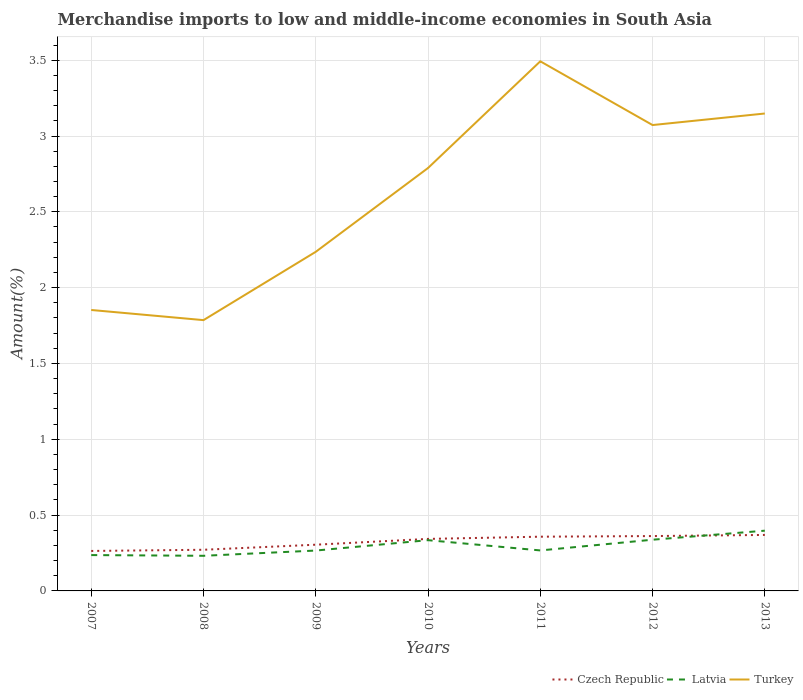Does the line corresponding to Latvia intersect with the line corresponding to Czech Republic?
Provide a short and direct response. Yes. Across all years, what is the maximum percentage of amount earned from merchandise imports in Latvia?
Your response must be concise. 0.23. What is the total percentage of amount earned from merchandise imports in Latvia in the graph?
Provide a succinct answer. -0.1. What is the difference between the highest and the second highest percentage of amount earned from merchandise imports in Czech Republic?
Offer a terse response. 0.11. How many lines are there?
Keep it short and to the point. 3. How many years are there in the graph?
Ensure brevity in your answer.  7. What is the difference between two consecutive major ticks on the Y-axis?
Your answer should be compact. 0.5. Are the values on the major ticks of Y-axis written in scientific E-notation?
Your response must be concise. No. How many legend labels are there?
Offer a terse response. 3. How are the legend labels stacked?
Offer a very short reply. Horizontal. What is the title of the graph?
Offer a very short reply. Merchandise imports to low and middle-income economies in South Asia. What is the label or title of the X-axis?
Make the answer very short. Years. What is the label or title of the Y-axis?
Your answer should be very brief. Amount(%). What is the Amount(%) in Czech Republic in 2007?
Make the answer very short. 0.26. What is the Amount(%) in Latvia in 2007?
Provide a succinct answer. 0.24. What is the Amount(%) in Turkey in 2007?
Ensure brevity in your answer.  1.85. What is the Amount(%) of Czech Republic in 2008?
Your answer should be very brief. 0.27. What is the Amount(%) of Latvia in 2008?
Ensure brevity in your answer.  0.23. What is the Amount(%) in Turkey in 2008?
Your response must be concise. 1.79. What is the Amount(%) of Czech Republic in 2009?
Offer a very short reply. 0.3. What is the Amount(%) in Latvia in 2009?
Offer a very short reply. 0.27. What is the Amount(%) of Turkey in 2009?
Ensure brevity in your answer.  2.24. What is the Amount(%) of Czech Republic in 2010?
Ensure brevity in your answer.  0.34. What is the Amount(%) in Latvia in 2010?
Provide a succinct answer. 0.33. What is the Amount(%) in Turkey in 2010?
Provide a short and direct response. 2.79. What is the Amount(%) of Czech Republic in 2011?
Your response must be concise. 0.36. What is the Amount(%) of Latvia in 2011?
Your answer should be compact. 0.27. What is the Amount(%) in Turkey in 2011?
Your answer should be very brief. 3.49. What is the Amount(%) in Czech Republic in 2012?
Provide a succinct answer. 0.36. What is the Amount(%) of Latvia in 2012?
Your response must be concise. 0.34. What is the Amount(%) of Turkey in 2012?
Ensure brevity in your answer.  3.07. What is the Amount(%) of Czech Republic in 2013?
Give a very brief answer. 0.37. What is the Amount(%) of Latvia in 2013?
Offer a terse response. 0.4. What is the Amount(%) in Turkey in 2013?
Give a very brief answer. 3.15. Across all years, what is the maximum Amount(%) of Czech Republic?
Your response must be concise. 0.37. Across all years, what is the maximum Amount(%) of Latvia?
Provide a succinct answer. 0.4. Across all years, what is the maximum Amount(%) of Turkey?
Your answer should be compact. 3.49. Across all years, what is the minimum Amount(%) of Czech Republic?
Make the answer very short. 0.26. Across all years, what is the minimum Amount(%) in Latvia?
Provide a succinct answer. 0.23. Across all years, what is the minimum Amount(%) in Turkey?
Provide a succinct answer. 1.79. What is the total Amount(%) in Czech Republic in the graph?
Provide a short and direct response. 2.27. What is the total Amount(%) of Latvia in the graph?
Your response must be concise. 2.07. What is the total Amount(%) in Turkey in the graph?
Your answer should be very brief. 18.38. What is the difference between the Amount(%) of Czech Republic in 2007 and that in 2008?
Make the answer very short. -0.01. What is the difference between the Amount(%) of Latvia in 2007 and that in 2008?
Your answer should be compact. 0. What is the difference between the Amount(%) of Turkey in 2007 and that in 2008?
Make the answer very short. 0.07. What is the difference between the Amount(%) in Czech Republic in 2007 and that in 2009?
Give a very brief answer. -0.04. What is the difference between the Amount(%) of Latvia in 2007 and that in 2009?
Ensure brevity in your answer.  -0.03. What is the difference between the Amount(%) in Turkey in 2007 and that in 2009?
Keep it short and to the point. -0.38. What is the difference between the Amount(%) of Czech Republic in 2007 and that in 2010?
Give a very brief answer. -0.08. What is the difference between the Amount(%) of Latvia in 2007 and that in 2010?
Offer a very short reply. -0.1. What is the difference between the Amount(%) of Turkey in 2007 and that in 2010?
Your response must be concise. -0.94. What is the difference between the Amount(%) in Czech Republic in 2007 and that in 2011?
Ensure brevity in your answer.  -0.09. What is the difference between the Amount(%) in Latvia in 2007 and that in 2011?
Provide a succinct answer. -0.03. What is the difference between the Amount(%) of Turkey in 2007 and that in 2011?
Keep it short and to the point. -1.64. What is the difference between the Amount(%) in Czech Republic in 2007 and that in 2012?
Offer a terse response. -0.1. What is the difference between the Amount(%) in Latvia in 2007 and that in 2012?
Make the answer very short. -0.1. What is the difference between the Amount(%) in Turkey in 2007 and that in 2012?
Your answer should be very brief. -1.22. What is the difference between the Amount(%) of Czech Republic in 2007 and that in 2013?
Keep it short and to the point. -0.11. What is the difference between the Amount(%) in Latvia in 2007 and that in 2013?
Offer a terse response. -0.16. What is the difference between the Amount(%) in Turkey in 2007 and that in 2013?
Offer a very short reply. -1.3. What is the difference between the Amount(%) in Czech Republic in 2008 and that in 2009?
Your answer should be compact. -0.03. What is the difference between the Amount(%) of Latvia in 2008 and that in 2009?
Offer a terse response. -0.03. What is the difference between the Amount(%) in Turkey in 2008 and that in 2009?
Offer a very short reply. -0.45. What is the difference between the Amount(%) in Czech Republic in 2008 and that in 2010?
Keep it short and to the point. -0.07. What is the difference between the Amount(%) of Latvia in 2008 and that in 2010?
Make the answer very short. -0.1. What is the difference between the Amount(%) in Turkey in 2008 and that in 2010?
Provide a succinct answer. -1. What is the difference between the Amount(%) of Czech Republic in 2008 and that in 2011?
Your answer should be compact. -0.09. What is the difference between the Amount(%) in Latvia in 2008 and that in 2011?
Your response must be concise. -0.04. What is the difference between the Amount(%) in Turkey in 2008 and that in 2011?
Offer a very short reply. -1.71. What is the difference between the Amount(%) of Czech Republic in 2008 and that in 2012?
Your answer should be very brief. -0.09. What is the difference between the Amount(%) of Latvia in 2008 and that in 2012?
Provide a short and direct response. -0.11. What is the difference between the Amount(%) of Turkey in 2008 and that in 2012?
Offer a terse response. -1.29. What is the difference between the Amount(%) in Czech Republic in 2008 and that in 2013?
Make the answer very short. -0.1. What is the difference between the Amount(%) of Latvia in 2008 and that in 2013?
Offer a very short reply. -0.17. What is the difference between the Amount(%) of Turkey in 2008 and that in 2013?
Your answer should be very brief. -1.36. What is the difference between the Amount(%) of Czech Republic in 2009 and that in 2010?
Give a very brief answer. -0.04. What is the difference between the Amount(%) in Latvia in 2009 and that in 2010?
Ensure brevity in your answer.  -0.07. What is the difference between the Amount(%) in Turkey in 2009 and that in 2010?
Offer a terse response. -0.55. What is the difference between the Amount(%) of Czech Republic in 2009 and that in 2011?
Ensure brevity in your answer.  -0.05. What is the difference between the Amount(%) in Latvia in 2009 and that in 2011?
Your response must be concise. -0. What is the difference between the Amount(%) of Turkey in 2009 and that in 2011?
Ensure brevity in your answer.  -1.26. What is the difference between the Amount(%) in Czech Republic in 2009 and that in 2012?
Keep it short and to the point. -0.06. What is the difference between the Amount(%) of Latvia in 2009 and that in 2012?
Your answer should be very brief. -0.07. What is the difference between the Amount(%) in Turkey in 2009 and that in 2012?
Offer a terse response. -0.84. What is the difference between the Amount(%) in Czech Republic in 2009 and that in 2013?
Provide a succinct answer. -0.06. What is the difference between the Amount(%) of Latvia in 2009 and that in 2013?
Ensure brevity in your answer.  -0.13. What is the difference between the Amount(%) of Turkey in 2009 and that in 2013?
Your answer should be very brief. -0.91. What is the difference between the Amount(%) of Czech Republic in 2010 and that in 2011?
Ensure brevity in your answer.  -0.01. What is the difference between the Amount(%) in Latvia in 2010 and that in 2011?
Your response must be concise. 0.07. What is the difference between the Amount(%) of Turkey in 2010 and that in 2011?
Ensure brevity in your answer.  -0.7. What is the difference between the Amount(%) of Czech Republic in 2010 and that in 2012?
Offer a terse response. -0.02. What is the difference between the Amount(%) in Latvia in 2010 and that in 2012?
Give a very brief answer. -0. What is the difference between the Amount(%) in Turkey in 2010 and that in 2012?
Keep it short and to the point. -0.28. What is the difference between the Amount(%) of Czech Republic in 2010 and that in 2013?
Ensure brevity in your answer.  -0.03. What is the difference between the Amount(%) in Latvia in 2010 and that in 2013?
Your response must be concise. -0.06. What is the difference between the Amount(%) in Turkey in 2010 and that in 2013?
Ensure brevity in your answer.  -0.36. What is the difference between the Amount(%) of Czech Republic in 2011 and that in 2012?
Provide a short and direct response. -0. What is the difference between the Amount(%) in Latvia in 2011 and that in 2012?
Provide a succinct answer. -0.07. What is the difference between the Amount(%) of Turkey in 2011 and that in 2012?
Your response must be concise. 0.42. What is the difference between the Amount(%) of Czech Republic in 2011 and that in 2013?
Offer a very short reply. -0.01. What is the difference between the Amount(%) in Latvia in 2011 and that in 2013?
Keep it short and to the point. -0.13. What is the difference between the Amount(%) in Turkey in 2011 and that in 2013?
Your response must be concise. 0.34. What is the difference between the Amount(%) of Czech Republic in 2012 and that in 2013?
Provide a short and direct response. -0.01. What is the difference between the Amount(%) in Latvia in 2012 and that in 2013?
Make the answer very short. -0.06. What is the difference between the Amount(%) in Turkey in 2012 and that in 2013?
Your response must be concise. -0.08. What is the difference between the Amount(%) in Czech Republic in 2007 and the Amount(%) in Latvia in 2008?
Offer a very short reply. 0.03. What is the difference between the Amount(%) of Czech Republic in 2007 and the Amount(%) of Turkey in 2008?
Your answer should be compact. -1.52. What is the difference between the Amount(%) of Latvia in 2007 and the Amount(%) of Turkey in 2008?
Provide a succinct answer. -1.55. What is the difference between the Amount(%) of Czech Republic in 2007 and the Amount(%) of Latvia in 2009?
Provide a succinct answer. -0. What is the difference between the Amount(%) of Czech Republic in 2007 and the Amount(%) of Turkey in 2009?
Your answer should be compact. -1.97. What is the difference between the Amount(%) of Latvia in 2007 and the Amount(%) of Turkey in 2009?
Provide a succinct answer. -2. What is the difference between the Amount(%) of Czech Republic in 2007 and the Amount(%) of Latvia in 2010?
Your answer should be compact. -0.07. What is the difference between the Amount(%) of Czech Republic in 2007 and the Amount(%) of Turkey in 2010?
Offer a very short reply. -2.53. What is the difference between the Amount(%) of Latvia in 2007 and the Amount(%) of Turkey in 2010?
Give a very brief answer. -2.55. What is the difference between the Amount(%) of Czech Republic in 2007 and the Amount(%) of Latvia in 2011?
Provide a short and direct response. -0. What is the difference between the Amount(%) in Czech Republic in 2007 and the Amount(%) in Turkey in 2011?
Offer a very short reply. -3.23. What is the difference between the Amount(%) in Latvia in 2007 and the Amount(%) in Turkey in 2011?
Provide a short and direct response. -3.26. What is the difference between the Amount(%) of Czech Republic in 2007 and the Amount(%) of Latvia in 2012?
Your response must be concise. -0.07. What is the difference between the Amount(%) of Czech Republic in 2007 and the Amount(%) of Turkey in 2012?
Offer a very short reply. -2.81. What is the difference between the Amount(%) of Latvia in 2007 and the Amount(%) of Turkey in 2012?
Offer a terse response. -2.84. What is the difference between the Amount(%) in Czech Republic in 2007 and the Amount(%) in Latvia in 2013?
Give a very brief answer. -0.13. What is the difference between the Amount(%) in Czech Republic in 2007 and the Amount(%) in Turkey in 2013?
Your response must be concise. -2.88. What is the difference between the Amount(%) of Latvia in 2007 and the Amount(%) of Turkey in 2013?
Provide a succinct answer. -2.91. What is the difference between the Amount(%) of Czech Republic in 2008 and the Amount(%) of Latvia in 2009?
Provide a short and direct response. 0.01. What is the difference between the Amount(%) in Czech Republic in 2008 and the Amount(%) in Turkey in 2009?
Ensure brevity in your answer.  -1.97. What is the difference between the Amount(%) of Latvia in 2008 and the Amount(%) of Turkey in 2009?
Offer a terse response. -2. What is the difference between the Amount(%) in Czech Republic in 2008 and the Amount(%) in Latvia in 2010?
Give a very brief answer. -0.06. What is the difference between the Amount(%) in Czech Republic in 2008 and the Amount(%) in Turkey in 2010?
Provide a succinct answer. -2.52. What is the difference between the Amount(%) in Latvia in 2008 and the Amount(%) in Turkey in 2010?
Offer a terse response. -2.56. What is the difference between the Amount(%) in Czech Republic in 2008 and the Amount(%) in Latvia in 2011?
Ensure brevity in your answer.  0. What is the difference between the Amount(%) in Czech Republic in 2008 and the Amount(%) in Turkey in 2011?
Provide a succinct answer. -3.22. What is the difference between the Amount(%) of Latvia in 2008 and the Amount(%) of Turkey in 2011?
Your answer should be compact. -3.26. What is the difference between the Amount(%) of Czech Republic in 2008 and the Amount(%) of Latvia in 2012?
Give a very brief answer. -0.07. What is the difference between the Amount(%) in Czech Republic in 2008 and the Amount(%) in Turkey in 2012?
Offer a very short reply. -2.8. What is the difference between the Amount(%) of Latvia in 2008 and the Amount(%) of Turkey in 2012?
Offer a terse response. -2.84. What is the difference between the Amount(%) of Czech Republic in 2008 and the Amount(%) of Latvia in 2013?
Offer a very short reply. -0.13. What is the difference between the Amount(%) in Czech Republic in 2008 and the Amount(%) in Turkey in 2013?
Offer a terse response. -2.88. What is the difference between the Amount(%) in Latvia in 2008 and the Amount(%) in Turkey in 2013?
Your answer should be very brief. -2.92. What is the difference between the Amount(%) in Czech Republic in 2009 and the Amount(%) in Latvia in 2010?
Make the answer very short. -0.03. What is the difference between the Amount(%) of Czech Republic in 2009 and the Amount(%) of Turkey in 2010?
Your answer should be compact. -2.48. What is the difference between the Amount(%) in Latvia in 2009 and the Amount(%) in Turkey in 2010?
Keep it short and to the point. -2.52. What is the difference between the Amount(%) of Czech Republic in 2009 and the Amount(%) of Latvia in 2011?
Offer a very short reply. 0.04. What is the difference between the Amount(%) in Czech Republic in 2009 and the Amount(%) in Turkey in 2011?
Provide a succinct answer. -3.19. What is the difference between the Amount(%) in Latvia in 2009 and the Amount(%) in Turkey in 2011?
Make the answer very short. -3.23. What is the difference between the Amount(%) in Czech Republic in 2009 and the Amount(%) in Latvia in 2012?
Provide a succinct answer. -0.03. What is the difference between the Amount(%) of Czech Republic in 2009 and the Amount(%) of Turkey in 2012?
Give a very brief answer. -2.77. What is the difference between the Amount(%) of Latvia in 2009 and the Amount(%) of Turkey in 2012?
Offer a very short reply. -2.81. What is the difference between the Amount(%) of Czech Republic in 2009 and the Amount(%) of Latvia in 2013?
Your response must be concise. -0.09. What is the difference between the Amount(%) of Czech Republic in 2009 and the Amount(%) of Turkey in 2013?
Provide a succinct answer. -2.84. What is the difference between the Amount(%) of Latvia in 2009 and the Amount(%) of Turkey in 2013?
Your answer should be compact. -2.88. What is the difference between the Amount(%) of Czech Republic in 2010 and the Amount(%) of Latvia in 2011?
Your answer should be very brief. 0.08. What is the difference between the Amount(%) of Czech Republic in 2010 and the Amount(%) of Turkey in 2011?
Your answer should be compact. -3.15. What is the difference between the Amount(%) of Latvia in 2010 and the Amount(%) of Turkey in 2011?
Ensure brevity in your answer.  -3.16. What is the difference between the Amount(%) in Czech Republic in 2010 and the Amount(%) in Latvia in 2012?
Your response must be concise. 0.01. What is the difference between the Amount(%) of Czech Republic in 2010 and the Amount(%) of Turkey in 2012?
Give a very brief answer. -2.73. What is the difference between the Amount(%) in Latvia in 2010 and the Amount(%) in Turkey in 2012?
Your answer should be very brief. -2.74. What is the difference between the Amount(%) in Czech Republic in 2010 and the Amount(%) in Latvia in 2013?
Offer a terse response. -0.05. What is the difference between the Amount(%) in Czech Republic in 2010 and the Amount(%) in Turkey in 2013?
Provide a succinct answer. -2.81. What is the difference between the Amount(%) in Latvia in 2010 and the Amount(%) in Turkey in 2013?
Make the answer very short. -2.81. What is the difference between the Amount(%) in Czech Republic in 2011 and the Amount(%) in Latvia in 2012?
Your answer should be compact. 0.02. What is the difference between the Amount(%) of Czech Republic in 2011 and the Amount(%) of Turkey in 2012?
Your answer should be very brief. -2.71. What is the difference between the Amount(%) of Latvia in 2011 and the Amount(%) of Turkey in 2012?
Provide a succinct answer. -2.81. What is the difference between the Amount(%) of Czech Republic in 2011 and the Amount(%) of Latvia in 2013?
Your response must be concise. -0.04. What is the difference between the Amount(%) of Czech Republic in 2011 and the Amount(%) of Turkey in 2013?
Make the answer very short. -2.79. What is the difference between the Amount(%) in Latvia in 2011 and the Amount(%) in Turkey in 2013?
Make the answer very short. -2.88. What is the difference between the Amount(%) in Czech Republic in 2012 and the Amount(%) in Latvia in 2013?
Your response must be concise. -0.04. What is the difference between the Amount(%) of Czech Republic in 2012 and the Amount(%) of Turkey in 2013?
Keep it short and to the point. -2.79. What is the difference between the Amount(%) in Latvia in 2012 and the Amount(%) in Turkey in 2013?
Offer a terse response. -2.81. What is the average Amount(%) of Czech Republic per year?
Ensure brevity in your answer.  0.32. What is the average Amount(%) in Latvia per year?
Your answer should be compact. 0.3. What is the average Amount(%) of Turkey per year?
Provide a succinct answer. 2.63. In the year 2007, what is the difference between the Amount(%) of Czech Republic and Amount(%) of Latvia?
Offer a terse response. 0.03. In the year 2007, what is the difference between the Amount(%) in Czech Republic and Amount(%) in Turkey?
Your response must be concise. -1.59. In the year 2007, what is the difference between the Amount(%) in Latvia and Amount(%) in Turkey?
Provide a succinct answer. -1.62. In the year 2008, what is the difference between the Amount(%) of Czech Republic and Amount(%) of Latvia?
Offer a terse response. 0.04. In the year 2008, what is the difference between the Amount(%) of Czech Republic and Amount(%) of Turkey?
Your response must be concise. -1.51. In the year 2008, what is the difference between the Amount(%) of Latvia and Amount(%) of Turkey?
Ensure brevity in your answer.  -1.55. In the year 2009, what is the difference between the Amount(%) in Czech Republic and Amount(%) in Latvia?
Provide a short and direct response. 0.04. In the year 2009, what is the difference between the Amount(%) of Czech Republic and Amount(%) of Turkey?
Keep it short and to the point. -1.93. In the year 2009, what is the difference between the Amount(%) in Latvia and Amount(%) in Turkey?
Your answer should be compact. -1.97. In the year 2010, what is the difference between the Amount(%) in Czech Republic and Amount(%) in Latvia?
Provide a short and direct response. 0.01. In the year 2010, what is the difference between the Amount(%) in Czech Republic and Amount(%) in Turkey?
Make the answer very short. -2.45. In the year 2010, what is the difference between the Amount(%) of Latvia and Amount(%) of Turkey?
Your answer should be very brief. -2.45. In the year 2011, what is the difference between the Amount(%) in Czech Republic and Amount(%) in Latvia?
Keep it short and to the point. 0.09. In the year 2011, what is the difference between the Amount(%) of Czech Republic and Amount(%) of Turkey?
Offer a terse response. -3.14. In the year 2011, what is the difference between the Amount(%) of Latvia and Amount(%) of Turkey?
Your response must be concise. -3.23. In the year 2012, what is the difference between the Amount(%) in Czech Republic and Amount(%) in Latvia?
Your answer should be compact. 0.02. In the year 2012, what is the difference between the Amount(%) of Czech Republic and Amount(%) of Turkey?
Provide a short and direct response. -2.71. In the year 2012, what is the difference between the Amount(%) of Latvia and Amount(%) of Turkey?
Offer a terse response. -2.73. In the year 2013, what is the difference between the Amount(%) of Czech Republic and Amount(%) of Latvia?
Keep it short and to the point. -0.03. In the year 2013, what is the difference between the Amount(%) of Czech Republic and Amount(%) of Turkey?
Provide a short and direct response. -2.78. In the year 2013, what is the difference between the Amount(%) in Latvia and Amount(%) in Turkey?
Your answer should be very brief. -2.75. What is the ratio of the Amount(%) of Czech Republic in 2007 to that in 2008?
Provide a succinct answer. 0.97. What is the ratio of the Amount(%) in Latvia in 2007 to that in 2008?
Offer a very short reply. 1.02. What is the ratio of the Amount(%) of Turkey in 2007 to that in 2008?
Your answer should be very brief. 1.04. What is the ratio of the Amount(%) of Czech Republic in 2007 to that in 2009?
Your response must be concise. 0.86. What is the ratio of the Amount(%) in Latvia in 2007 to that in 2009?
Offer a very short reply. 0.89. What is the ratio of the Amount(%) in Turkey in 2007 to that in 2009?
Give a very brief answer. 0.83. What is the ratio of the Amount(%) in Czech Republic in 2007 to that in 2010?
Your answer should be compact. 0.77. What is the ratio of the Amount(%) in Latvia in 2007 to that in 2010?
Provide a succinct answer. 0.71. What is the ratio of the Amount(%) of Turkey in 2007 to that in 2010?
Offer a terse response. 0.66. What is the ratio of the Amount(%) in Czech Republic in 2007 to that in 2011?
Make the answer very short. 0.74. What is the ratio of the Amount(%) in Latvia in 2007 to that in 2011?
Your response must be concise. 0.89. What is the ratio of the Amount(%) of Turkey in 2007 to that in 2011?
Your answer should be very brief. 0.53. What is the ratio of the Amount(%) in Czech Republic in 2007 to that in 2012?
Ensure brevity in your answer.  0.73. What is the ratio of the Amount(%) in Latvia in 2007 to that in 2012?
Give a very brief answer. 0.7. What is the ratio of the Amount(%) of Turkey in 2007 to that in 2012?
Ensure brevity in your answer.  0.6. What is the ratio of the Amount(%) of Czech Republic in 2007 to that in 2013?
Keep it short and to the point. 0.71. What is the ratio of the Amount(%) in Latvia in 2007 to that in 2013?
Keep it short and to the point. 0.59. What is the ratio of the Amount(%) in Turkey in 2007 to that in 2013?
Give a very brief answer. 0.59. What is the ratio of the Amount(%) of Czech Republic in 2008 to that in 2009?
Keep it short and to the point. 0.89. What is the ratio of the Amount(%) of Latvia in 2008 to that in 2009?
Your answer should be very brief. 0.87. What is the ratio of the Amount(%) of Turkey in 2008 to that in 2009?
Offer a very short reply. 0.8. What is the ratio of the Amount(%) in Czech Republic in 2008 to that in 2010?
Ensure brevity in your answer.  0.79. What is the ratio of the Amount(%) in Latvia in 2008 to that in 2010?
Your answer should be very brief. 0.69. What is the ratio of the Amount(%) in Turkey in 2008 to that in 2010?
Keep it short and to the point. 0.64. What is the ratio of the Amount(%) of Czech Republic in 2008 to that in 2011?
Keep it short and to the point. 0.76. What is the ratio of the Amount(%) in Latvia in 2008 to that in 2011?
Ensure brevity in your answer.  0.87. What is the ratio of the Amount(%) in Turkey in 2008 to that in 2011?
Give a very brief answer. 0.51. What is the ratio of the Amount(%) of Czech Republic in 2008 to that in 2012?
Offer a terse response. 0.75. What is the ratio of the Amount(%) in Latvia in 2008 to that in 2012?
Offer a terse response. 0.69. What is the ratio of the Amount(%) of Turkey in 2008 to that in 2012?
Make the answer very short. 0.58. What is the ratio of the Amount(%) of Czech Republic in 2008 to that in 2013?
Your response must be concise. 0.73. What is the ratio of the Amount(%) of Latvia in 2008 to that in 2013?
Give a very brief answer. 0.58. What is the ratio of the Amount(%) of Turkey in 2008 to that in 2013?
Your answer should be compact. 0.57. What is the ratio of the Amount(%) in Czech Republic in 2009 to that in 2010?
Ensure brevity in your answer.  0.89. What is the ratio of the Amount(%) in Latvia in 2009 to that in 2010?
Make the answer very short. 0.8. What is the ratio of the Amount(%) in Turkey in 2009 to that in 2010?
Your answer should be compact. 0.8. What is the ratio of the Amount(%) in Czech Republic in 2009 to that in 2011?
Offer a very short reply. 0.85. What is the ratio of the Amount(%) in Latvia in 2009 to that in 2011?
Ensure brevity in your answer.  1. What is the ratio of the Amount(%) of Turkey in 2009 to that in 2011?
Provide a short and direct response. 0.64. What is the ratio of the Amount(%) of Czech Republic in 2009 to that in 2012?
Your answer should be compact. 0.84. What is the ratio of the Amount(%) of Latvia in 2009 to that in 2012?
Offer a very short reply. 0.79. What is the ratio of the Amount(%) in Turkey in 2009 to that in 2012?
Offer a very short reply. 0.73. What is the ratio of the Amount(%) in Czech Republic in 2009 to that in 2013?
Offer a terse response. 0.83. What is the ratio of the Amount(%) in Latvia in 2009 to that in 2013?
Your answer should be very brief. 0.67. What is the ratio of the Amount(%) in Turkey in 2009 to that in 2013?
Ensure brevity in your answer.  0.71. What is the ratio of the Amount(%) in Latvia in 2010 to that in 2011?
Your response must be concise. 1.25. What is the ratio of the Amount(%) in Turkey in 2010 to that in 2011?
Ensure brevity in your answer.  0.8. What is the ratio of the Amount(%) of Czech Republic in 2010 to that in 2012?
Your answer should be very brief. 0.95. What is the ratio of the Amount(%) in Turkey in 2010 to that in 2012?
Ensure brevity in your answer.  0.91. What is the ratio of the Amount(%) in Czech Republic in 2010 to that in 2013?
Offer a very short reply. 0.93. What is the ratio of the Amount(%) of Latvia in 2010 to that in 2013?
Your response must be concise. 0.84. What is the ratio of the Amount(%) of Turkey in 2010 to that in 2013?
Your response must be concise. 0.89. What is the ratio of the Amount(%) of Czech Republic in 2011 to that in 2012?
Provide a short and direct response. 0.99. What is the ratio of the Amount(%) in Latvia in 2011 to that in 2012?
Offer a terse response. 0.79. What is the ratio of the Amount(%) in Turkey in 2011 to that in 2012?
Provide a succinct answer. 1.14. What is the ratio of the Amount(%) in Czech Republic in 2011 to that in 2013?
Ensure brevity in your answer.  0.97. What is the ratio of the Amount(%) in Latvia in 2011 to that in 2013?
Keep it short and to the point. 0.67. What is the ratio of the Amount(%) in Turkey in 2011 to that in 2013?
Your answer should be compact. 1.11. What is the ratio of the Amount(%) of Czech Republic in 2012 to that in 2013?
Offer a very short reply. 0.98. What is the ratio of the Amount(%) of Turkey in 2012 to that in 2013?
Ensure brevity in your answer.  0.98. What is the difference between the highest and the second highest Amount(%) in Czech Republic?
Make the answer very short. 0.01. What is the difference between the highest and the second highest Amount(%) of Latvia?
Offer a very short reply. 0.06. What is the difference between the highest and the second highest Amount(%) in Turkey?
Your answer should be very brief. 0.34. What is the difference between the highest and the lowest Amount(%) of Czech Republic?
Ensure brevity in your answer.  0.11. What is the difference between the highest and the lowest Amount(%) of Latvia?
Offer a very short reply. 0.17. What is the difference between the highest and the lowest Amount(%) of Turkey?
Give a very brief answer. 1.71. 